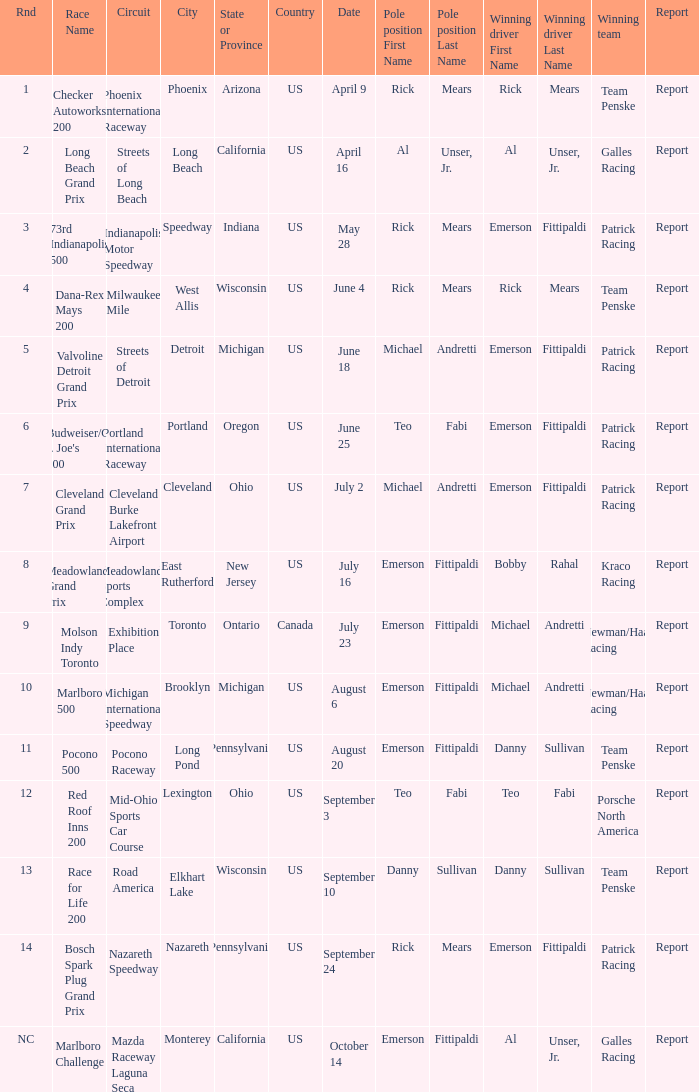What report was there for the porsche north america? Report. 